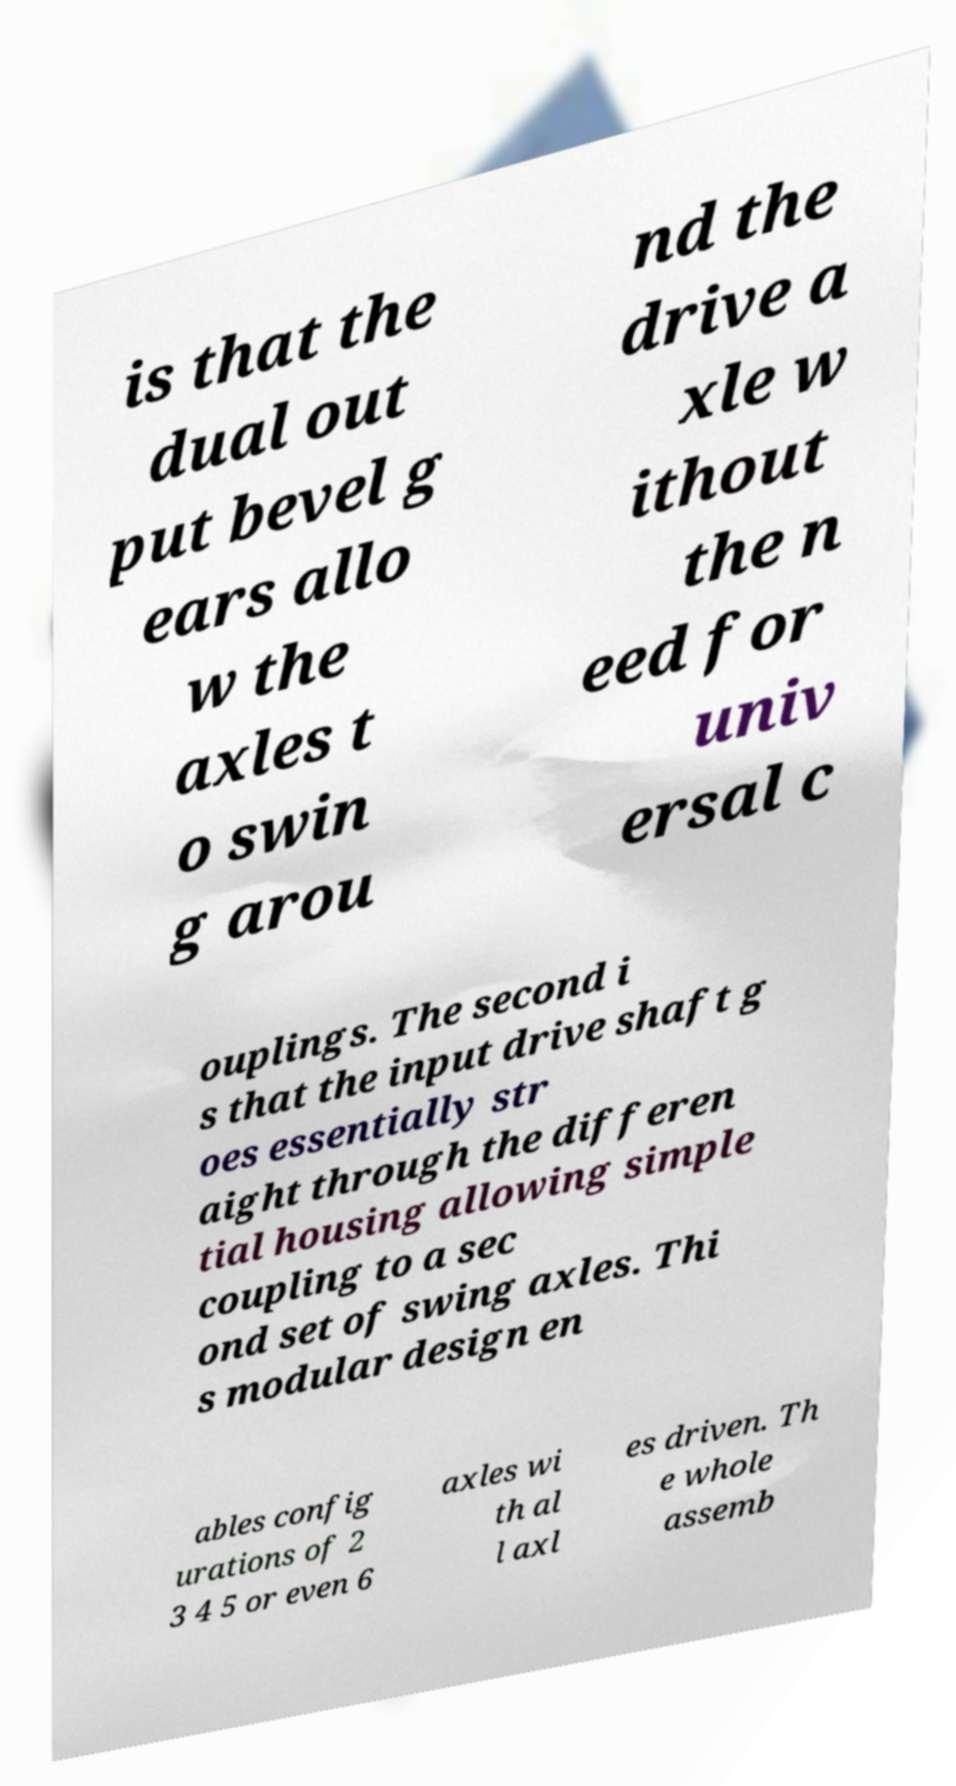Can you accurately transcribe the text from the provided image for me? is that the dual out put bevel g ears allo w the axles t o swin g arou nd the drive a xle w ithout the n eed for univ ersal c ouplings. The second i s that the input drive shaft g oes essentially str aight through the differen tial housing allowing simple coupling to a sec ond set of swing axles. Thi s modular design en ables config urations of 2 3 4 5 or even 6 axles wi th al l axl es driven. Th e whole assemb 